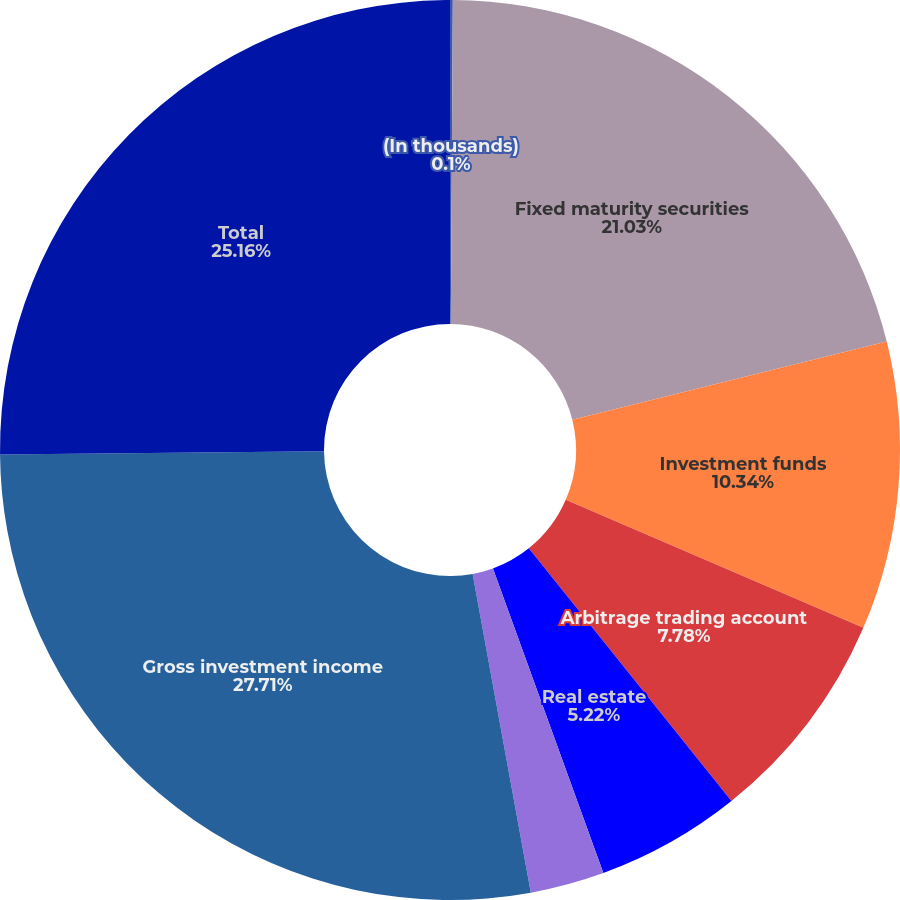Convert chart to OTSL. <chart><loc_0><loc_0><loc_500><loc_500><pie_chart><fcel>(In thousands)<fcel>Fixed maturity securities<fcel>Investment funds<fcel>Arbitrage trading account<fcel>Real estate<fcel>Equity securities available<fcel>Gross investment income<fcel>Total<nl><fcel>0.1%<fcel>21.03%<fcel>10.34%<fcel>7.78%<fcel>5.22%<fcel>2.66%<fcel>27.72%<fcel>25.16%<nl></chart> 